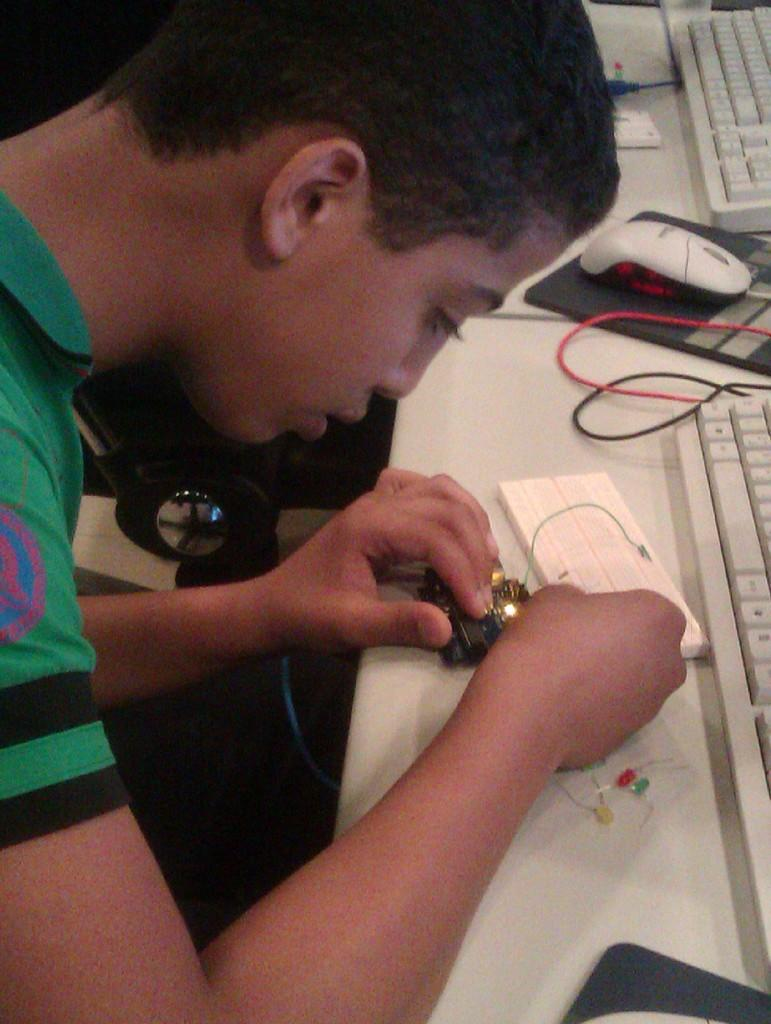What is the person in the image holding? The person is holding an object in the image. What type of objects can be seen in the image? There are electrical objects and keyboards in the image. Can you describe the mouse in the image? There is a mouse in the image, which is likely a computer mouse. What else can be seen in the image related to computer equipment? There are cables in the image. How many babies are visible in the image? There are no babies present in the image. What color is the nose of the person in the image? The image does not show the person's nose, so it cannot be determined. 